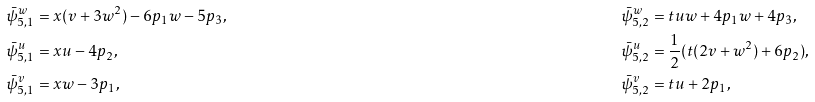Convert formula to latex. <formula><loc_0><loc_0><loc_500><loc_500>& \bar { \psi } _ { 5 , 1 } ^ { w } = x ( v + 3 w ^ { 2 } ) - 6 p _ { 1 } w - 5 p _ { 3 } , & & \bar { \psi } _ { 5 , 2 } ^ { w } = t u w + 4 p _ { 1 } w + 4 p _ { 3 } , \\ & \bar { \psi } _ { 5 , 1 } ^ { u } = x u - 4 p _ { 2 } , & & \bar { \psi } _ { 5 , 2 } ^ { u } = \frac { 1 } { 2 } ( t ( 2 v + w ^ { 2 } ) + 6 p _ { 2 } ) , \\ & \bar { \psi } _ { 5 , 1 } ^ { v } = x w - 3 p _ { 1 } , & & \bar { \psi } _ { 5 , 2 } ^ { v } = t u + 2 p _ { 1 } ,</formula> 